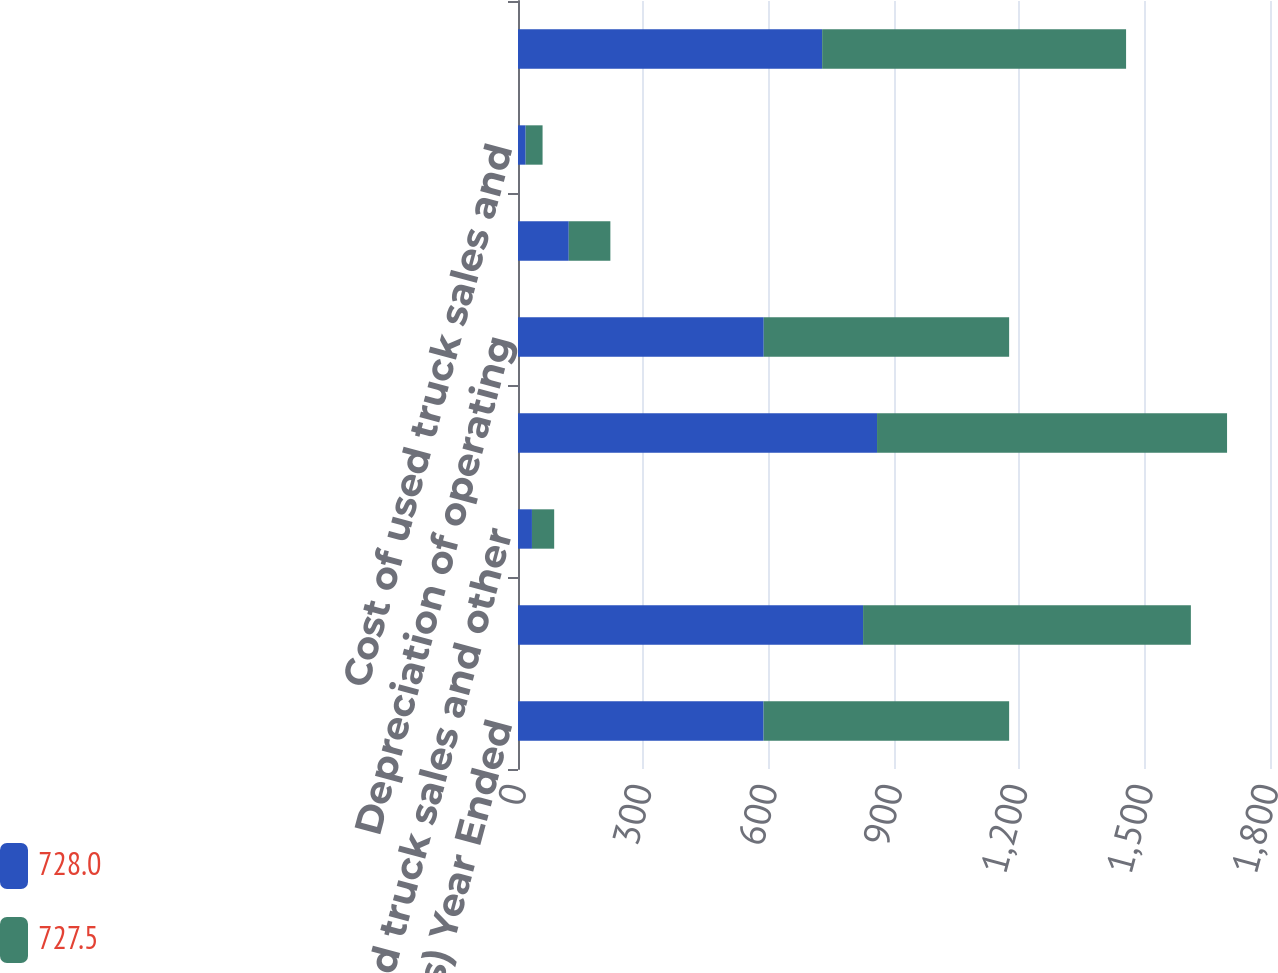Convert chart. <chart><loc_0><loc_0><loc_500><loc_500><stacked_bar_chart><ecel><fcel>( in millions) Year Ended<fcel>Operating lease and rental<fcel>Used truck sales and other<fcel>Operating lease rental and<fcel>Depreciation of operating<fcel>Vehicle operating expenses<fcel>Cost of used truck sales and<fcel>Depreciation and other<nl><fcel>728<fcel>587.8<fcel>826<fcel>33.4<fcel>859.4<fcel>588.2<fcel>121.5<fcel>18.3<fcel>728<nl><fcel>727.5<fcel>587.8<fcel>784.6<fcel>53.2<fcel>837.8<fcel>587.4<fcel>99.6<fcel>40.5<fcel>727.5<nl></chart> 